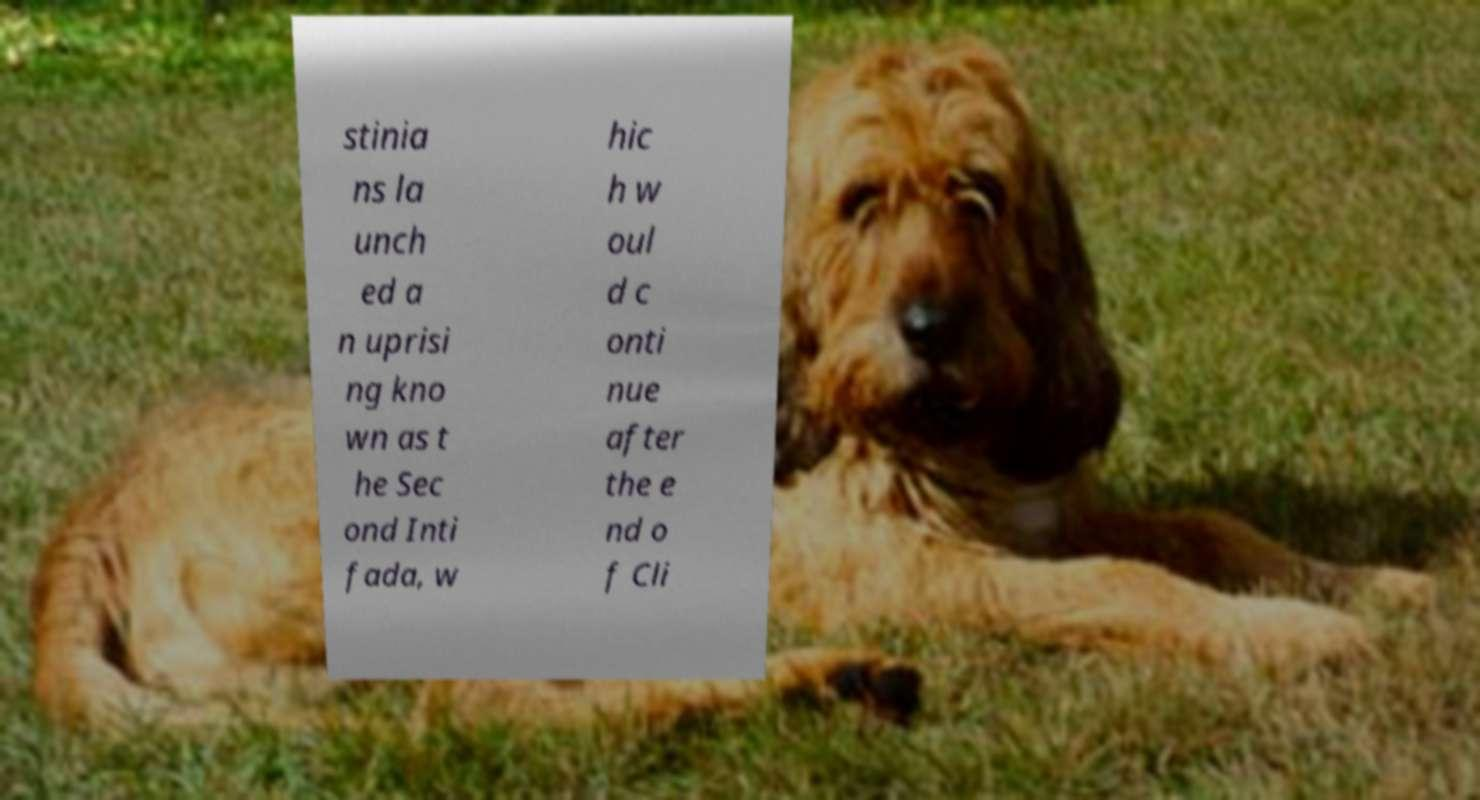Can you read and provide the text displayed in the image?This photo seems to have some interesting text. Can you extract and type it out for me? stinia ns la unch ed a n uprisi ng kno wn as t he Sec ond Inti fada, w hic h w oul d c onti nue after the e nd o f Cli 